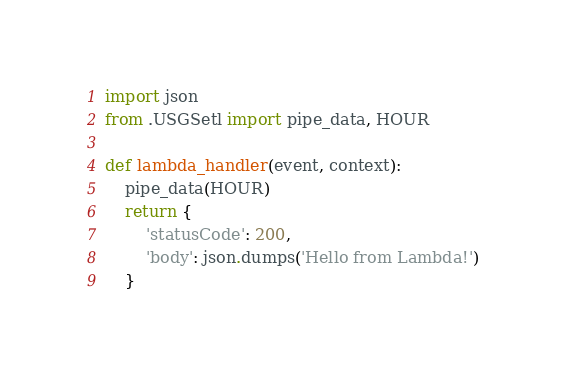<code> <loc_0><loc_0><loc_500><loc_500><_Python_>import json
from .USGSetl import pipe_data, HOUR

def lambda_handler(event, context):
    pipe_data(HOUR)
    return {
        'statusCode': 200,
        'body': json.dumps('Hello from Lambda!')
    }
</code> 